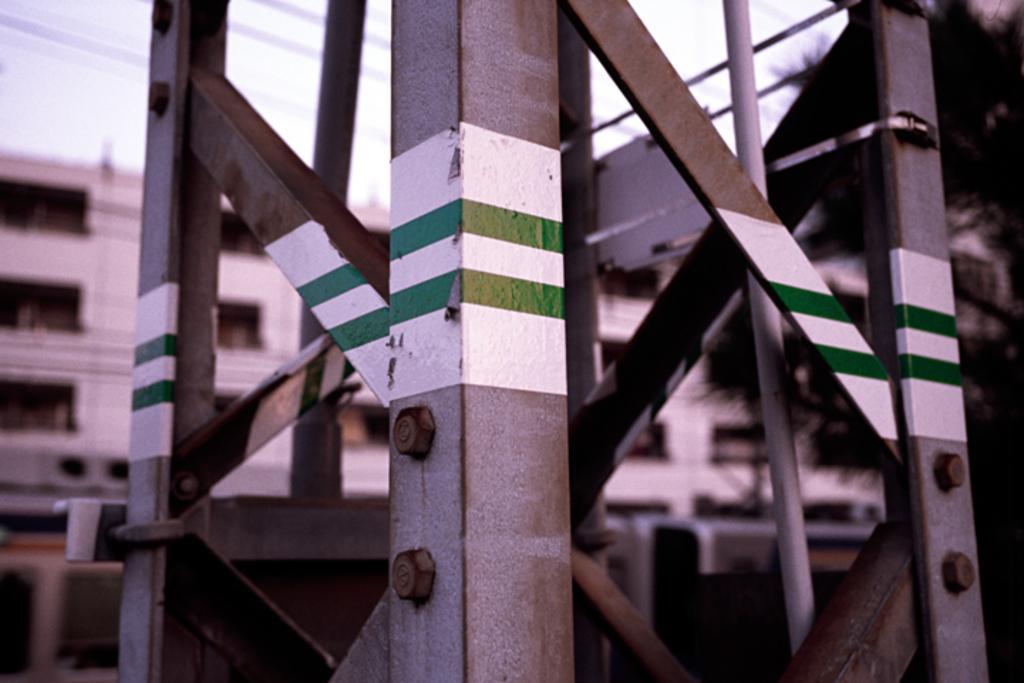Describe this image in one or two sentences. In this image I can see a tower which is made of metal rods to which I can see a paint which is white and green in color. In the background I can see a building which is which in color, a tree, few wires and the sky. 